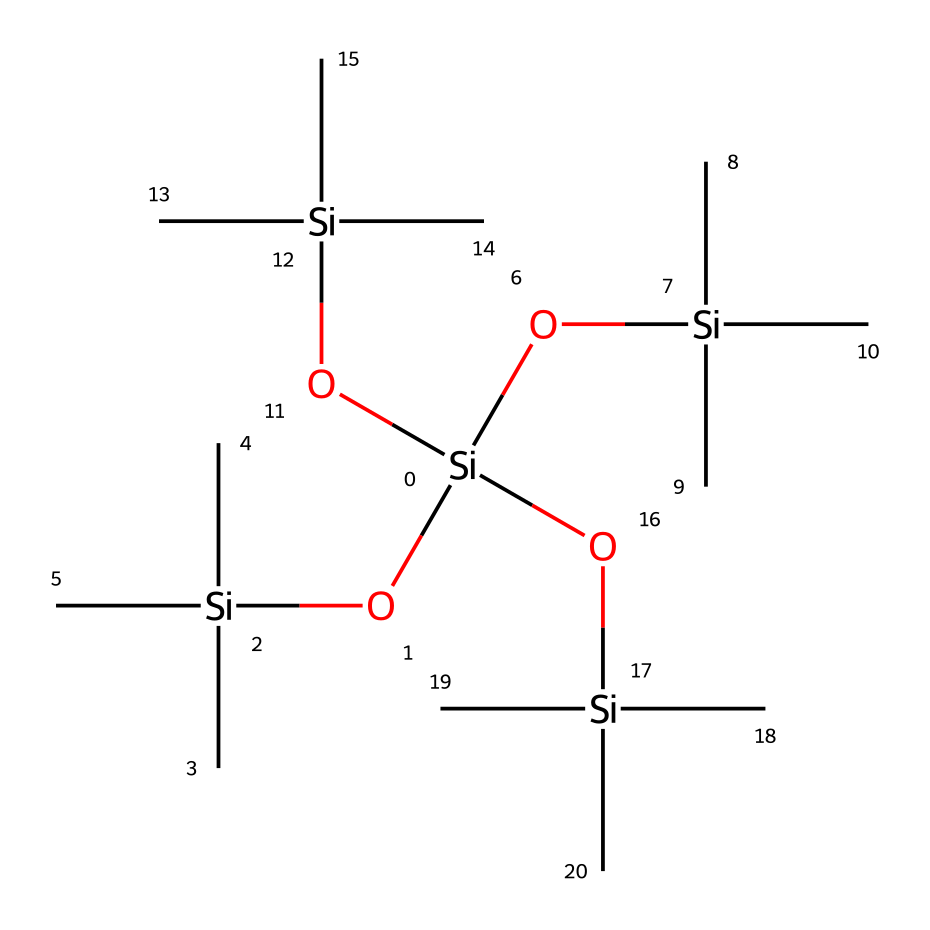what is the chemical type of this compound? This compound is an organosilicon compound because it contains silicon (Si) atoms bonded with organic groups, specifically alkyl groups (methyl groups in this case).
Answer: organosilicon compound how many silicon atoms are present in this structure? By examining the SMILES notation, we can count four silicon atoms indicated by the symbol 'Si' in the chemical structure.
Answer: four how many oxygen atoms are present in this structure? The SMILES notation shows a total of four oxygen atoms as indicated by the symbol 'O' in the chemical, which can be counted directly.
Answer: four what type of organic groups are attached to the silicon atoms? The organic groups attached to the silicon atoms in this structure are isopropyl groups, represented by the notation '[Si](C)(C)C' which indicates branching from the silicon.
Answer: isopropyl groups what kind of properties do silicone-based hair products typically have? Silicone-based hair products usually possess properties such as providing shine, reducing frizz, and enhancing smoothness due to the hydrophobic nature of silicons.
Answer: shine and smoothness describe the bonding type present between silicon and oxygen in this compound. The bonding between silicon and oxygen in this compound is characterized as covalent bonding where the silicon atom shares electrons with the oxygen atom, resulting in strong interactions that are beneficial for the stability of silicone products.
Answer: covalent bonding how does the structure of this compound contribute to its usability in hair products? The structure's siloxane bonds (Si-O) create a flexible and durable framework, which allows for the smooth application and coating of hair strands, making it ideal for hair products.
Answer: flexible and durable 